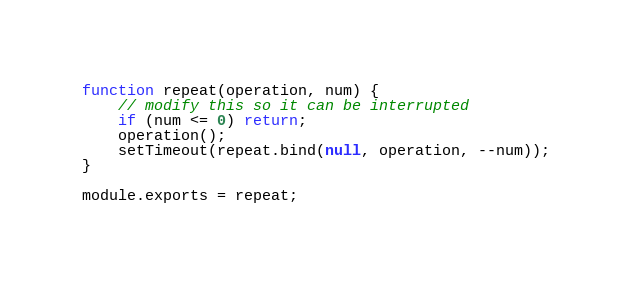<code> <loc_0><loc_0><loc_500><loc_500><_JavaScript_>function repeat(operation, num) {
    // modify this so it can be interrupted
    if (num <= 0) return;
    operation();
    setTimeout(repeat.bind(null, operation, --num));
}

module.exports = repeat;
</code> 